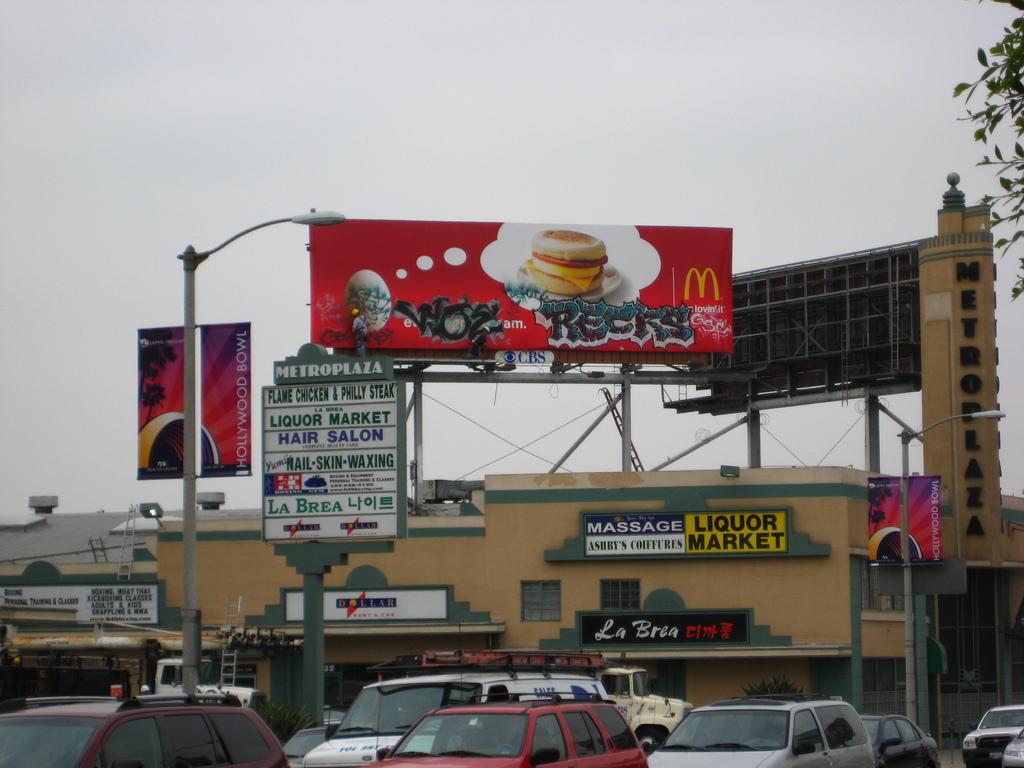Which fast food restaurant is advertised on the red billboard?
Offer a terse response. Mcdonalds. What can you purchase in the market?
Give a very brief answer. Liquor. 